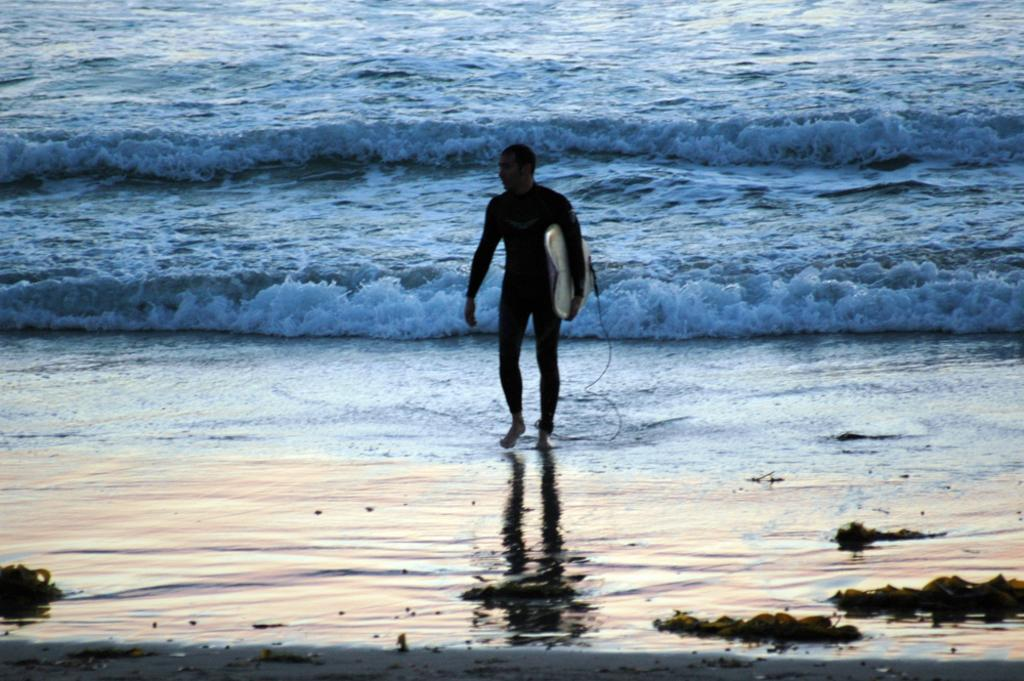Who is present in the image? There is a man in the image. What is the man doing in the image? The man is walking in the image. What is the man holding in the image? The man is holding a surfboard in the image. What can be seen in the background of the image? There are water waves in the background of the image. What type of rail can be seen in the image? There is no rail present in the image. Is the man writing in a notebook in the image? There is no notebook present in the image. 